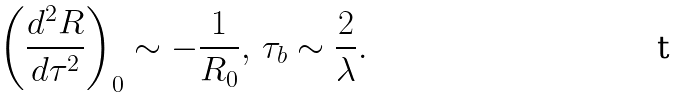<formula> <loc_0><loc_0><loc_500><loc_500>\left ( \frac { d ^ { 2 } R } { d \tau ^ { 2 } } \right ) _ { 0 } \sim - \frac { 1 } { R _ { 0 } } , \, \tau _ { b } \sim \frac { 2 } { \lambda } .</formula> 